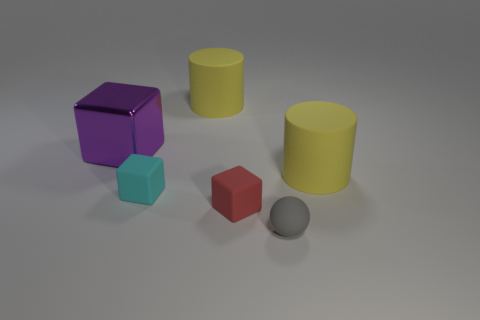Add 2 small yellow cubes. How many objects exist? 8 Subtract all cylinders. How many objects are left? 4 Add 1 big purple metal cubes. How many big purple metal cubes are left? 2 Add 1 large balls. How many large balls exist? 1 Subtract 0 brown cylinders. How many objects are left? 6 Subtract all small red matte objects. Subtract all small things. How many objects are left? 2 